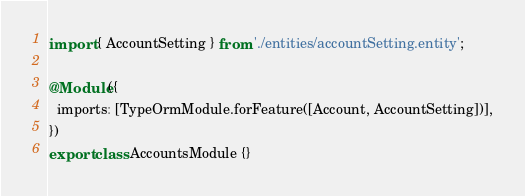Convert code to text. <code><loc_0><loc_0><loc_500><loc_500><_TypeScript_>import { AccountSetting } from './entities/accountSetting.entity';

@Module({
  imports: [TypeOrmModule.forFeature([Account, AccountSetting])],
})
export class AccountsModule {}
</code> 